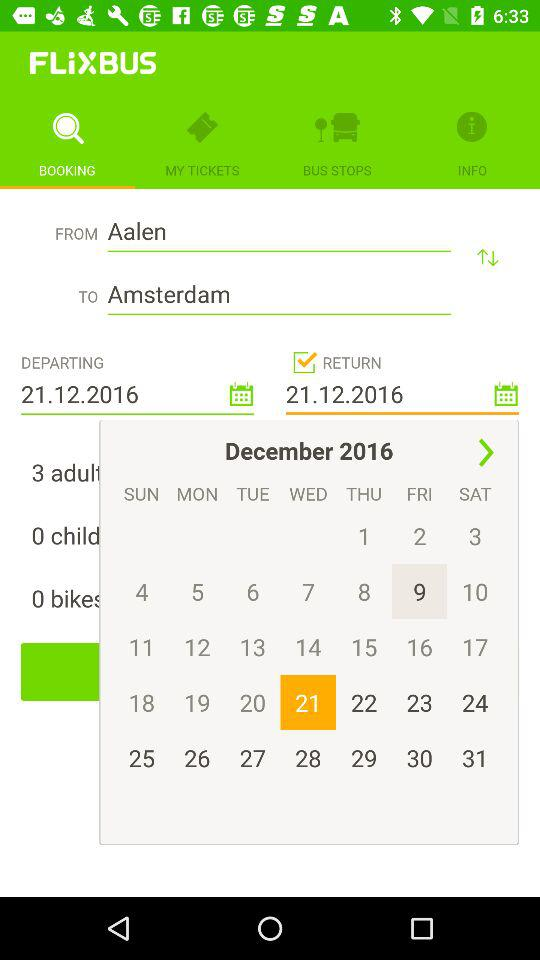What is the departure date? The departure date is December 21, 2016. 